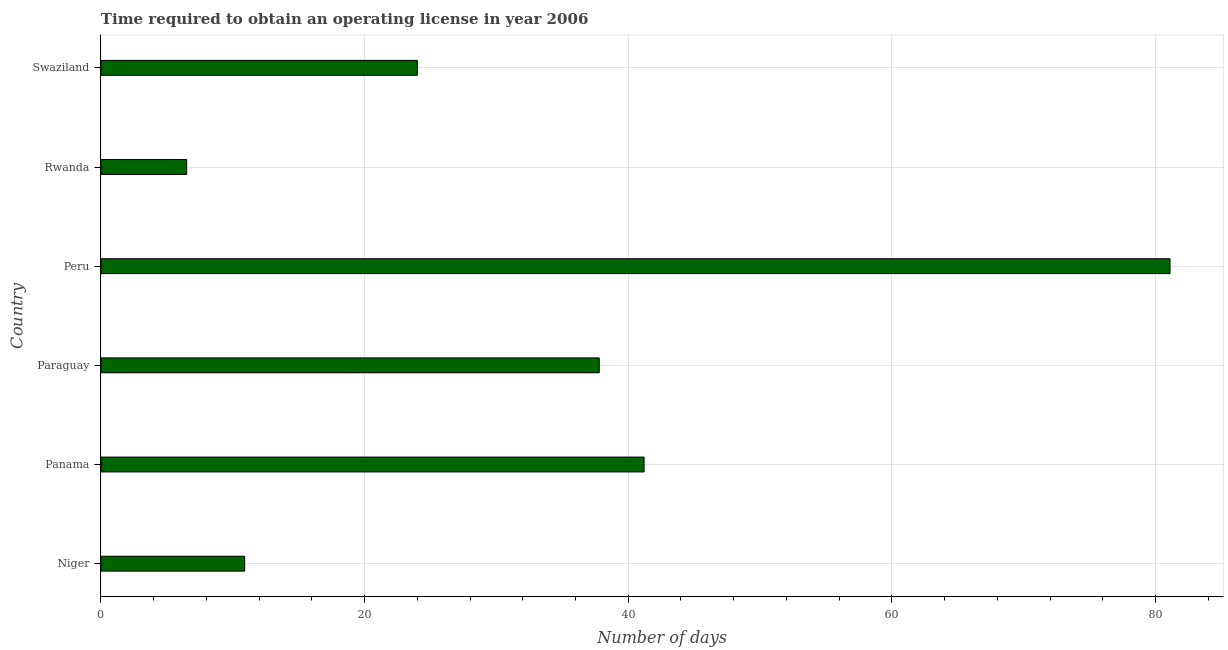Does the graph contain grids?
Offer a terse response. Yes. What is the title of the graph?
Provide a succinct answer. Time required to obtain an operating license in year 2006. What is the label or title of the X-axis?
Keep it short and to the point. Number of days. What is the number of days to obtain operating license in Rwanda?
Offer a very short reply. 6.5. Across all countries, what is the maximum number of days to obtain operating license?
Provide a succinct answer. 81.1. In which country was the number of days to obtain operating license minimum?
Provide a succinct answer. Rwanda. What is the sum of the number of days to obtain operating license?
Offer a terse response. 201.5. What is the difference between the number of days to obtain operating license in Niger and Peru?
Your answer should be very brief. -70.2. What is the average number of days to obtain operating license per country?
Give a very brief answer. 33.58. What is the median number of days to obtain operating license?
Provide a succinct answer. 30.9. In how many countries, is the number of days to obtain operating license greater than 68 days?
Ensure brevity in your answer.  1. What is the ratio of the number of days to obtain operating license in Panama to that in Paraguay?
Ensure brevity in your answer.  1.09. Is the number of days to obtain operating license in Panama less than that in Swaziland?
Your answer should be compact. No. What is the difference between the highest and the second highest number of days to obtain operating license?
Offer a very short reply. 39.9. Is the sum of the number of days to obtain operating license in Panama and Swaziland greater than the maximum number of days to obtain operating license across all countries?
Ensure brevity in your answer.  No. What is the difference between the highest and the lowest number of days to obtain operating license?
Keep it short and to the point. 74.6. In how many countries, is the number of days to obtain operating license greater than the average number of days to obtain operating license taken over all countries?
Your response must be concise. 3. How many bars are there?
Offer a terse response. 6. Are all the bars in the graph horizontal?
Keep it short and to the point. Yes. What is the difference between two consecutive major ticks on the X-axis?
Ensure brevity in your answer.  20. Are the values on the major ticks of X-axis written in scientific E-notation?
Give a very brief answer. No. What is the Number of days in Panama?
Offer a very short reply. 41.2. What is the Number of days of Paraguay?
Provide a succinct answer. 37.8. What is the Number of days of Peru?
Offer a very short reply. 81.1. What is the Number of days of Rwanda?
Make the answer very short. 6.5. What is the difference between the Number of days in Niger and Panama?
Your response must be concise. -30.3. What is the difference between the Number of days in Niger and Paraguay?
Give a very brief answer. -26.9. What is the difference between the Number of days in Niger and Peru?
Make the answer very short. -70.2. What is the difference between the Number of days in Niger and Rwanda?
Provide a succinct answer. 4.4. What is the difference between the Number of days in Niger and Swaziland?
Your answer should be very brief. -13.1. What is the difference between the Number of days in Panama and Paraguay?
Your answer should be very brief. 3.4. What is the difference between the Number of days in Panama and Peru?
Make the answer very short. -39.9. What is the difference between the Number of days in Panama and Rwanda?
Provide a short and direct response. 34.7. What is the difference between the Number of days in Panama and Swaziland?
Your response must be concise. 17.2. What is the difference between the Number of days in Paraguay and Peru?
Offer a terse response. -43.3. What is the difference between the Number of days in Paraguay and Rwanda?
Offer a very short reply. 31.3. What is the difference between the Number of days in Paraguay and Swaziland?
Keep it short and to the point. 13.8. What is the difference between the Number of days in Peru and Rwanda?
Provide a short and direct response. 74.6. What is the difference between the Number of days in Peru and Swaziland?
Provide a short and direct response. 57.1. What is the difference between the Number of days in Rwanda and Swaziland?
Provide a short and direct response. -17.5. What is the ratio of the Number of days in Niger to that in Panama?
Your response must be concise. 0.27. What is the ratio of the Number of days in Niger to that in Paraguay?
Keep it short and to the point. 0.29. What is the ratio of the Number of days in Niger to that in Peru?
Give a very brief answer. 0.13. What is the ratio of the Number of days in Niger to that in Rwanda?
Your answer should be compact. 1.68. What is the ratio of the Number of days in Niger to that in Swaziland?
Ensure brevity in your answer.  0.45. What is the ratio of the Number of days in Panama to that in Paraguay?
Give a very brief answer. 1.09. What is the ratio of the Number of days in Panama to that in Peru?
Make the answer very short. 0.51. What is the ratio of the Number of days in Panama to that in Rwanda?
Make the answer very short. 6.34. What is the ratio of the Number of days in Panama to that in Swaziland?
Ensure brevity in your answer.  1.72. What is the ratio of the Number of days in Paraguay to that in Peru?
Your answer should be very brief. 0.47. What is the ratio of the Number of days in Paraguay to that in Rwanda?
Your answer should be compact. 5.82. What is the ratio of the Number of days in Paraguay to that in Swaziland?
Offer a terse response. 1.57. What is the ratio of the Number of days in Peru to that in Rwanda?
Provide a succinct answer. 12.48. What is the ratio of the Number of days in Peru to that in Swaziland?
Your answer should be compact. 3.38. What is the ratio of the Number of days in Rwanda to that in Swaziland?
Ensure brevity in your answer.  0.27. 